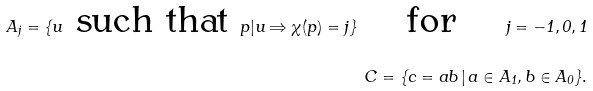Convert formula to latex. <formula><loc_0><loc_0><loc_500><loc_500>A _ { j } = \{ u \text { such that } p | u \Rightarrow \chi ( p ) = j \} \quad \text { for } \quad j = - 1 , 0 , 1 \\ C = \{ c = a b \, | \, a \in A _ { 1 } , b \in A _ { 0 } \} .</formula> 